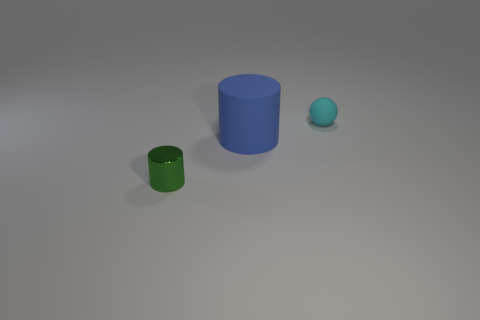Add 2 blue matte balls. How many objects exist? 5 Subtract all spheres. How many objects are left? 2 Add 3 balls. How many balls exist? 4 Subtract 0 brown cubes. How many objects are left? 3 Subtract all blue shiny objects. Subtract all blue cylinders. How many objects are left? 2 Add 1 shiny things. How many shiny things are left? 2 